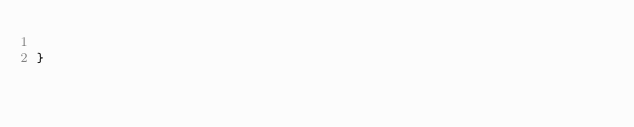<code> <loc_0><loc_0><loc_500><loc_500><_Java_>
}
</code> 